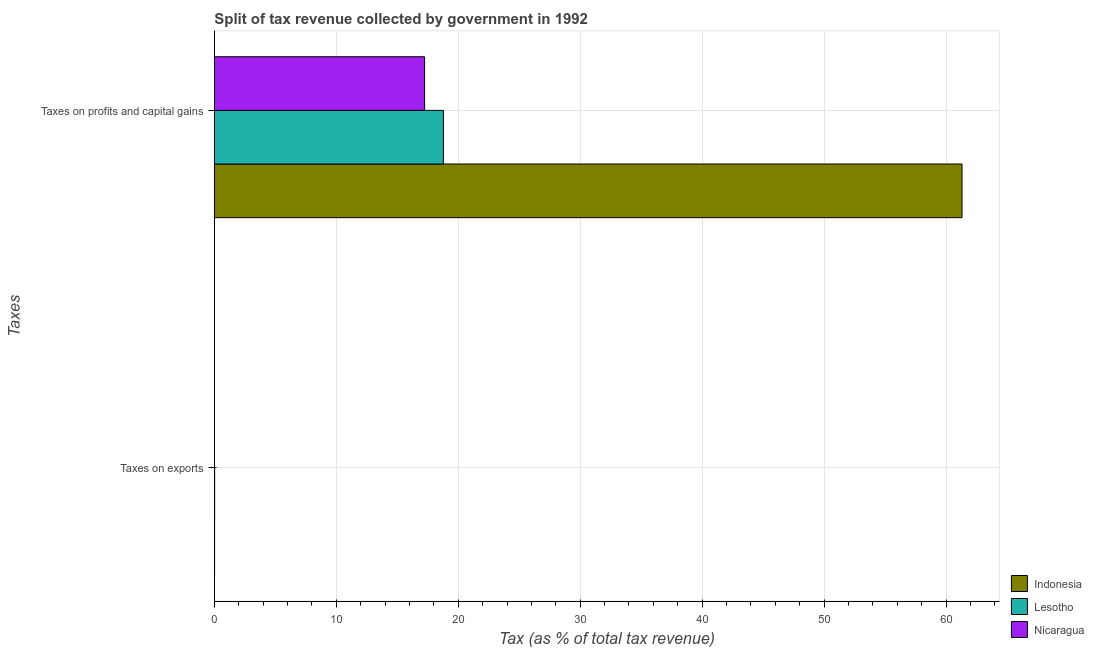How many different coloured bars are there?
Give a very brief answer. 3. How many groups of bars are there?
Ensure brevity in your answer.  2. Are the number of bars per tick equal to the number of legend labels?
Offer a terse response. Yes. Are the number of bars on each tick of the Y-axis equal?
Offer a very short reply. Yes. How many bars are there on the 1st tick from the top?
Your response must be concise. 3. What is the label of the 2nd group of bars from the top?
Keep it short and to the point. Taxes on exports. What is the percentage of revenue obtained from taxes on profits and capital gains in Nicaragua?
Your answer should be compact. 17.24. Across all countries, what is the maximum percentage of revenue obtained from taxes on exports?
Provide a succinct answer. 0.02. Across all countries, what is the minimum percentage of revenue obtained from taxes on exports?
Give a very brief answer. 0.01. In which country was the percentage of revenue obtained from taxes on exports maximum?
Your response must be concise. Lesotho. In which country was the percentage of revenue obtained from taxes on exports minimum?
Ensure brevity in your answer.  Nicaragua. What is the total percentage of revenue obtained from taxes on exports in the graph?
Offer a very short reply. 0.05. What is the difference between the percentage of revenue obtained from taxes on profits and capital gains in Nicaragua and that in Indonesia?
Your answer should be very brief. -44.07. What is the difference between the percentage of revenue obtained from taxes on profits and capital gains in Lesotho and the percentage of revenue obtained from taxes on exports in Indonesia?
Ensure brevity in your answer.  18.76. What is the average percentage of revenue obtained from taxes on exports per country?
Offer a terse response. 0.02. What is the difference between the percentage of revenue obtained from taxes on profits and capital gains and percentage of revenue obtained from taxes on exports in Lesotho?
Offer a very short reply. 18.76. What is the ratio of the percentage of revenue obtained from taxes on exports in Nicaragua to that in Lesotho?
Your response must be concise. 0.23. What does the 3rd bar from the top in Taxes on profits and capital gains represents?
Provide a succinct answer. Indonesia. What does the 2nd bar from the bottom in Taxes on profits and capital gains represents?
Give a very brief answer. Lesotho. How many bars are there?
Your answer should be compact. 6. How many countries are there in the graph?
Your answer should be compact. 3. Does the graph contain grids?
Ensure brevity in your answer.  Yes. Where does the legend appear in the graph?
Offer a very short reply. Bottom right. How many legend labels are there?
Ensure brevity in your answer.  3. How are the legend labels stacked?
Provide a short and direct response. Vertical. What is the title of the graph?
Your answer should be compact. Split of tax revenue collected by government in 1992. What is the label or title of the X-axis?
Ensure brevity in your answer.  Tax (as % of total tax revenue). What is the label or title of the Y-axis?
Give a very brief answer. Taxes. What is the Tax (as % of total tax revenue) in Indonesia in Taxes on exports?
Your response must be concise. 0.02. What is the Tax (as % of total tax revenue) in Lesotho in Taxes on exports?
Provide a short and direct response. 0.02. What is the Tax (as % of total tax revenue) in Nicaragua in Taxes on exports?
Make the answer very short. 0.01. What is the Tax (as % of total tax revenue) of Indonesia in Taxes on profits and capital gains?
Provide a succinct answer. 61.31. What is the Tax (as % of total tax revenue) in Lesotho in Taxes on profits and capital gains?
Your response must be concise. 18.78. What is the Tax (as % of total tax revenue) in Nicaragua in Taxes on profits and capital gains?
Provide a short and direct response. 17.24. Across all Taxes, what is the maximum Tax (as % of total tax revenue) of Indonesia?
Make the answer very short. 61.31. Across all Taxes, what is the maximum Tax (as % of total tax revenue) of Lesotho?
Provide a succinct answer. 18.78. Across all Taxes, what is the maximum Tax (as % of total tax revenue) in Nicaragua?
Offer a very short reply. 17.24. Across all Taxes, what is the minimum Tax (as % of total tax revenue) of Indonesia?
Give a very brief answer. 0.02. Across all Taxes, what is the minimum Tax (as % of total tax revenue) in Lesotho?
Keep it short and to the point. 0.02. Across all Taxes, what is the minimum Tax (as % of total tax revenue) in Nicaragua?
Provide a short and direct response. 0.01. What is the total Tax (as % of total tax revenue) in Indonesia in the graph?
Provide a short and direct response. 61.33. What is the total Tax (as % of total tax revenue) in Lesotho in the graph?
Your answer should be very brief. 18.81. What is the total Tax (as % of total tax revenue) in Nicaragua in the graph?
Your answer should be very brief. 17.25. What is the difference between the Tax (as % of total tax revenue) of Indonesia in Taxes on exports and that in Taxes on profits and capital gains?
Provide a succinct answer. -61.29. What is the difference between the Tax (as % of total tax revenue) in Lesotho in Taxes on exports and that in Taxes on profits and capital gains?
Provide a succinct answer. -18.76. What is the difference between the Tax (as % of total tax revenue) in Nicaragua in Taxes on exports and that in Taxes on profits and capital gains?
Your answer should be compact. -17.24. What is the difference between the Tax (as % of total tax revenue) in Indonesia in Taxes on exports and the Tax (as % of total tax revenue) in Lesotho in Taxes on profits and capital gains?
Your answer should be compact. -18.76. What is the difference between the Tax (as % of total tax revenue) of Indonesia in Taxes on exports and the Tax (as % of total tax revenue) of Nicaragua in Taxes on profits and capital gains?
Keep it short and to the point. -17.22. What is the difference between the Tax (as % of total tax revenue) in Lesotho in Taxes on exports and the Tax (as % of total tax revenue) in Nicaragua in Taxes on profits and capital gains?
Ensure brevity in your answer.  -17.22. What is the average Tax (as % of total tax revenue) in Indonesia per Taxes?
Make the answer very short. 30.66. What is the average Tax (as % of total tax revenue) in Lesotho per Taxes?
Your response must be concise. 9.4. What is the average Tax (as % of total tax revenue) in Nicaragua per Taxes?
Ensure brevity in your answer.  8.62. What is the difference between the Tax (as % of total tax revenue) in Indonesia and Tax (as % of total tax revenue) in Lesotho in Taxes on exports?
Offer a terse response. -0.01. What is the difference between the Tax (as % of total tax revenue) of Indonesia and Tax (as % of total tax revenue) of Nicaragua in Taxes on exports?
Ensure brevity in your answer.  0.01. What is the difference between the Tax (as % of total tax revenue) of Lesotho and Tax (as % of total tax revenue) of Nicaragua in Taxes on exports?
Give a very brief answer. 0.02. What is the difference between the Tax (as % of total tax revenue) of Indonesia and Tax (as % of total tax revenue) of Lesotho in Taxes on profits and capital gains?
Provide a succinct answer. 42.53. What is the difference between the Tax (as % of total tax revenue) in Indonesia and Tax (as % of total tax revenue) in Nicaragua in Taxes on profits and capital gains?
Ensure brevity in your answer.  44.07. What is the difference between the Tax (as % of total tax revenue) of Lesotho and Tax (as % of total tax revenue) of Nicaragua in Taxes on profits and capital gains?
Provide a short and direct response. 1.54. What is the ratio of the Tax (as % of total tax revenue) of Lesotho in Taxes on exports to that in Taxes on profits and capital gains?
Make the answer very short. 0. What is the difference between the highest and the second highest Tax (as % of total tax revenue) of Indonesia?
Give a very brief answer. 61.29. What is the difference between the highest and the second highest Tax (as % of total tax revenue) of Lesotho?
Keep it short and to the point. 18.76. What is the difference between the highest and the second highest Tax (as % of total tax revenue) of Nicaragua?
Make the answer very short. 17.24. What is the difference between the highest and the lowest Tax (as % of total tax revenue) in Indonesia?
Give a very brief answer. 61.29. What is the difference between the highest and the lowest Tax (as % of total tax revenue) in Lesotho?
Make the answer very short. 18.76. What is the difference between the highest and the lowest Tax (as % of total tax revenue) in Nicaragua?
Your answer should be compact. 17.24. 